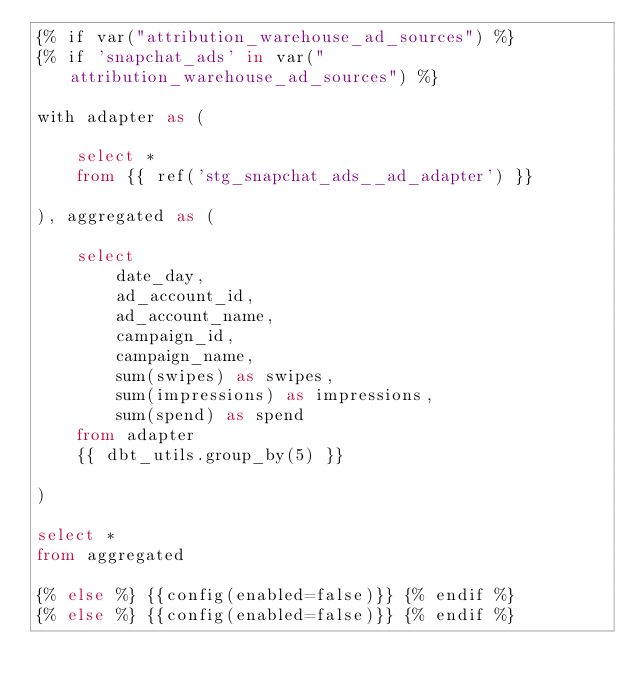<code> <loc_0><loc_0><loc_500><loc_500><_SQL_>{% if var("attribution_warehouse_ad_sources") %}
{% if 'snapchat_ads' in var("attribution_warehouse_ad_sources") %}

with adapter as (

    select *
    from {{ ref('stg_snapchat_ads__ad_adapter') }}

), aggregated as (

    select
        date_day,
        ad_account_id,
        ad_account_name,
        campaign_id,
        campaign_name,
        sum(swipes) as swipes,
        sum(impressions) as impressions,
        sum(spend) as spend
    from adapter
    {{ dbt_utils.group_by(5) }}

)

select *
from aggregated

{% else %} {{config(enabled=false)}} {% endif %}
{% else %} {{config(enabled=false)}} {% endif %}
</code> 